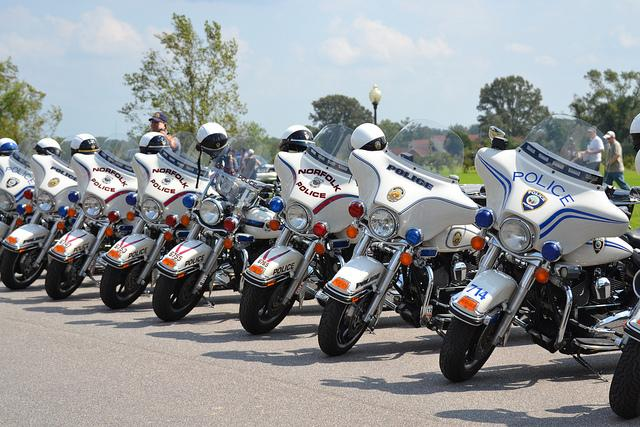What is beneath the number 714? Please explain your reasoning. tire. These are police motorcycles. the number 714 is on a fender. 